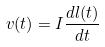<formula> <loc_0><loc_0><loc_500><loc_500>v ( t ) = I \frac { d l ( t ) } { d t }</formula> 